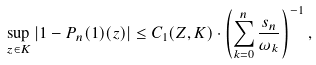Convert formula to latex. <formula><loc_0><loc_0><loc_500><loc_500>\sup _ { z \in K } | 1 - P _ { n } ( 1 ) ( z ) | \leq C _ { 1 } ( Z , K ) \cdot \left ( \sum _ { k = 0 } ^ { n } \frac { s _ { n } } { \omega _ { k } } \right ) ^ { - 1 } ,</formula> 